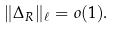Convert formula to latex. <formula><loc_0><loc_0><loc_500><loc_500>\| \Delta _ { R } \| _ { \ell } = o ( 1 ) .</formula> 